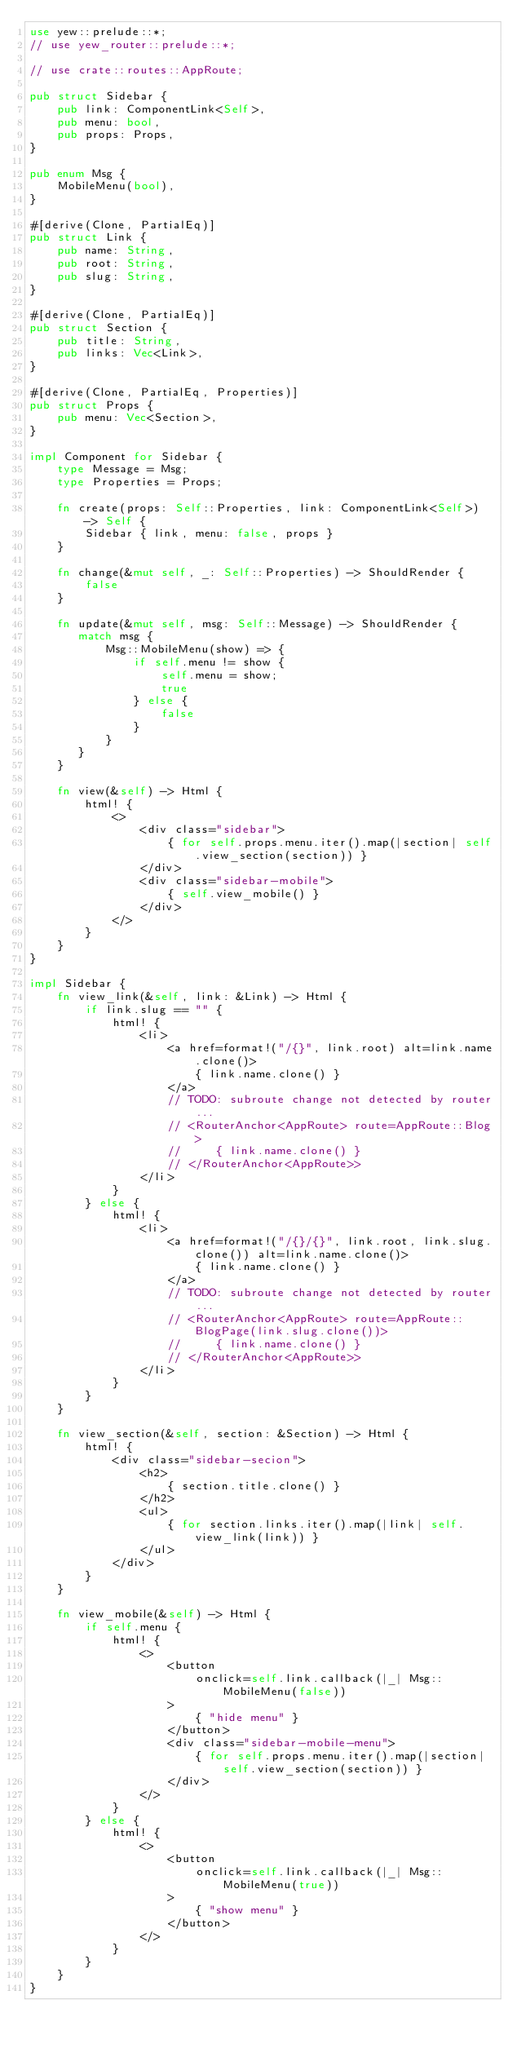Convert code to text. <code><loc_0><loc_0><loc_500><loc_500><_Rust_>use yew::prelude::*;
// use yew_router::prelude::*;

// use crate::routes::AppRoute;

pub struct Sidebar {
    pub link: ComponentLink<Self>,
    pub menu: bool,
    pub props: Props,
}

pub enum Msg {
    MobileMenu(bool),
}

#[derive(Clone, PartialEq)]
pub struct Link {
    pub name: String,
    pub root: String,
    pub slug: String,
}

#[derive(Clone, PartialEq)]
pub struct Section {
    pub title: String,
    pub links: Vec<Link>,
}

#[derive(Clone, PartialEq, Properties)]
pub struct Props {
    pub menu: Vec<Section>,
}

impl Component for Sidebar {
    type Message = Msg;
    type Properties = Props;

    fn create(props: Self::Properties, link: ComponentLink<Self>) -> Self {
        Sidebar { link, menu: false, props }
    }

    fn change(&mut self, _: Self::Properties) -> ShouldRender {
        false
    }

    fn update(&mut self, msg: Self::Message) -> ShouldRender {
       match msg {
           Msg::MobileMenu(show) => {
               if self.menu != show {
                   self.menu = show;
                   true
               } else {
                   false
               }
           }
       }
    }

    fn view(&self) -> Html {
        html! {
            <>
                <div class="sidebar">
                    { for self.props.menu.iter().map(|section| self.view_section(section)) }
                </div>
                <div class="sidebar-mobile">
                    { self.view_mobile() }
                </div>
            </>
        }
    }
}

impl Sidebar {
    fn view_link(&self, link: &Link) -> Html {
        if link.slug == "" {
            html! {
                <li>
                    <a href=format!("/{}", link.root) alt=link.name.clone()>
                        { link.name.clone() }
                    </a>
                    // TODO: subroute change not detected by router...
                    // <RouterAnchor<AppRoute> route=AppRoute::Blog>
                    //     { link.name.clone() }
                    // </RouterAnchor<AppRoute>>
                </li>
            }
        } else {
            html! {
                <li>
                    <a href=format!("/{}/{}", link.root, link.slug.clone()) alt=link.name.clone()>
                        { link.name.clone() }
                    </a>
                    // TODO: subroute change not detected by router...
                    // <RouterAnchor<AppRoute> route=AppRoute::BlogPage(link.slug.clone())>
                    //     { link.name.clone() }
                    // </RouterAnchor<AppRoute>>
                </li>
            }
        }
    }

    fn view_section(&self, section: &Section) -> Html {
        html! {
            <div class="sidebar-secion">
                <h2>
                    { section.title.clone() }
                </h2>
                <ul>
                    { for section.links.iter().map(|link| self.view_link(link)) }
                </ul>
            </div>
        }
    }

    fn view_mobile(&self) -> Html {
        if self.menu {
            html! {
                <>
                    <button
                        onclick=self.link.callback(|_| Msg::MobileMenu(false))
                    >
                        { "hide menu" }
                    </button>
                    <div class="sidebar-mobile-menu">
                        { for self.props.menu.iter().map(|section| self.view_section(section)) }
                    </div>
                </>
            }
        } else {
            html! {
                <>
                    <button
                        onclick=self.link.callback(|_| Msg::MobileMenu(true))
                    >
                        { "show menu" }
                    </button>
                </>
            }
        }
    }
}</code> 